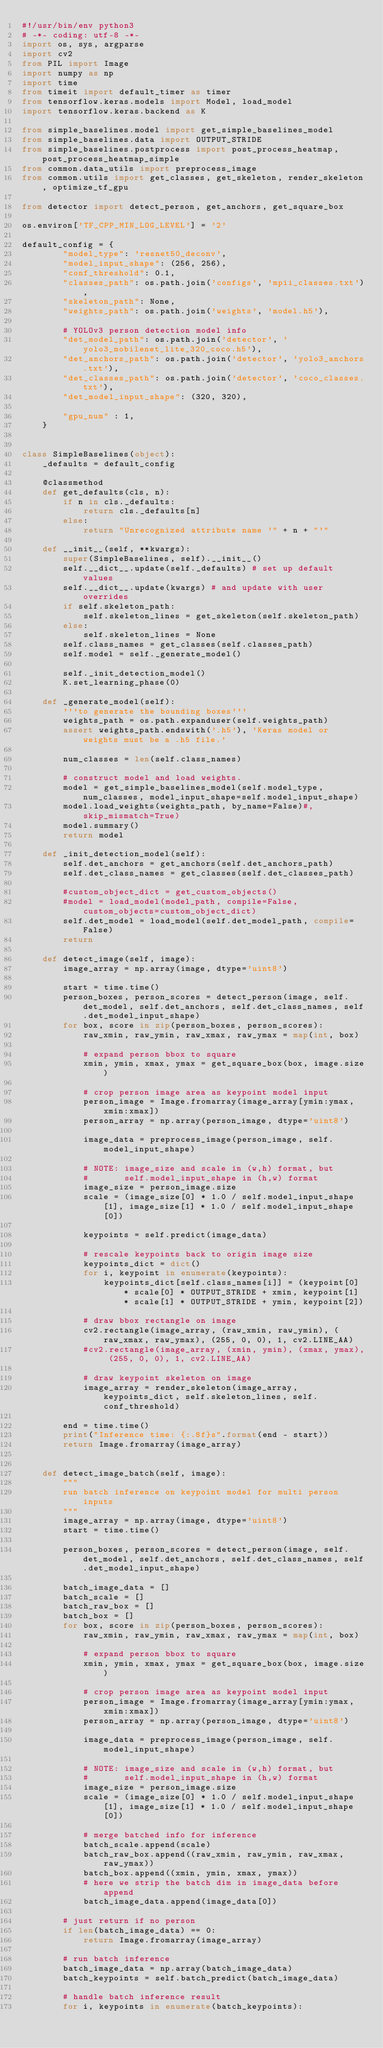<code> <loc_0><loc_0><loc_500><loc_500><_Python_>#!/usr/bin/env python3
# -*- coding: utf-8 -*-
import os, sys, argparse
import cv2
from PIL import Image
import numpy as np
import time
from timeit import default_timer as timer
from tensorflow.keras.models import Model, load_model
import tensorflow.keras.backend as K

from simple_baselines.model import get_simple_baselines_model
from simple_baselines.data import OUTPUT_STRIDE
from simple_baselines.postprocess import post_process_heatmap, post_process_heatmap_simple
from common.data_utils import preprocess_image
from common.utils import get_classes, get_skeleton, render_skeleton, optimize_tf_gpu

from detector import detect_person, get_anchors, get_square_box

os.environ['TF_CPP_MIN_LOG_LEVEL'] = '2'

default_config = {
        "model_type": 'resnet50_deconv',
        "model_input_shape": (256, 256),
        "conf_threshold": 0.1,
        "classes_path": os.path.join('configs', 'mpii_classes.txt'),
        "skeleton_path": None,
        "weights_path": os.path.join('weights', 'model.h5'),

        # YOLOv3 person detection model info
        "det_model_path": os.path.join('detector', 'yolo3_mobilenet_lite_320_coco.h5'),
        "det_anchors_path": os.path.join('detector', 'yolo3_anchors.txt'),
        "det_classes_path": os.path.join('detector', 'coco_classes.txt'),
        "det_model_input_shape": (320, 320),

        "gpu_num" : 1,
    }


class SimpleBaselines(object):
    _defaults = default_config

    @classmethod
    def get_defaults(cls, n):
        if n in cls._defaults:
            return cls._defaults[n]
        else:
            return "Unrecognized attribute name '" + n + "'"

    def __init__(self, **kwargs):
        super(SimpleBaselines, self).__init__()
        self.__dict__.update(self._defaults) # set up default values
        self.__dict__.update(kwargs) # and update with user overrides
        if self.skeleton_path:
            self.skeleton_lines = get_skeleton(self.skeleton_path)
        else:
            self.skeleton_lines = None
        self.class_names = get_classes(self.classes_path)
        self.model = self._generate_model()

        self._init_detection_model()
        K.set_learning_phase(0)

    def _generate_model(self):
        '''to generate the bounding boxes'''
        weights_path = os.path.expanduser(self.weights_path)
        assert weights_path.endswith('.h5'), 'Keras model or weights must be a .h5 file.'

        num_classes = len(self.class_names)

        # construct model and load weights.
        model = get_simple_baselines_model(self.model_type, num_classes, model_input_shape=self.model_input_shape)
        model.load_weights(weights_path, by_name=False)#, skip_mismatch=True)
        model.summary()
        return model

    def _init_detection_model(self):
        self.det_anchors = get_anchors(self.det_anchors_path)
        self.det_class_names = get_classes(self.det_classes_path)

        #custom_object_dict = get_custom_objects()
        #model = load_model(model_path, compile=False, custom_objects=custom_object_dict)
        self.det_model = load_model(self.det_model_path, compile=False)
        return

    def detect_image(self, image):
        image_array = np.array(image, dtype='uint8')

        start = time.time()
        person_boxes, person_scores = detect_person(image, self.det_model, self.det_anchors, self.det_class_names, self.det_model_input_shape)
        for box, score in zip(person_boxes, person_scores):
            raw_xmin, raw_ymin, raw_xmax, raw_ymax = map(int, box)

            # expand person bbox to square
            xmin, ymin, xmax, ymax = get_square_box(box, image.size)

            # crop person image area as keypoint model input
            person_image = Image.fromarray(image_array[ymin:ymax, xmin:xmax])
            person_array = np.array(person_image, dtype='uint8')

            image_data = preprocess_image(person_image, self.model_input_shape)

            # NOTE: image_size and scale in (w,h) format, but
            #       self.model_input_shape in (h,w) format
            image_size = person_image.size
            scale = (image_size[0] * 1.0 / self.model_input_shape[1], image_size[1] * 1.0 / self.model_input_shape[0])

            keypoints = self.predict(image_data)

            # rescale keypoints back to origin image size
            keypoints_dict = dict()
            for i, keypoint in enumerate(keypoints):
                keypoints_dict[self.class_names[i]] = (keypoint[0] * scale[0] * OUTPUT_STRIDE + xmin, keypoint[1] * scale[1] * OUTPUT_STRIDE + ymin, keypoint[2])

            # draw bbox rectangle on image
            cv2.rectangle(image_array, (raw_xmin, raw_ymin), (raw_xmax, raw_ymax), (255, 0, 0), 1, cv2.LINE_AA)
            #cv2.rectangle(image_array, (xmin, ymin), (xmax, ymax), (255, 0, 0), 1, cv2.LINE_AA)

            # draw keypoint skeleton on image
            image_array = render_skeleton(image_array, keypoints_dict, self.skeleton_lines, self.conf_threshold)

        end = time.time()
        print("Inference time: {:.8f}s".format(end - start))
        return Image.fromarray(image_array)


    def detect_image_batch(self, image):
        """
        run batch inference on keypoint model for multi person inputs
        """
        image_array = np.array(image, dtype='uint8')
        start = time.time()

        person_boxes, person_scores = detect_person(image, self.det_model, self.det_anchors, self.det_class_names, self.det_model_input_shape)

        batch_image_data = []
        batch_scale = []
        batch_raw_box = []
        batch_box = []
        for box, score in zip(person_boxes, person_scores):
            raw_xmin, raw_ymin, raw_xmax, raw_ymax = map(int, box)

            # expand person bbox to square
            xmin, ymin, xmax, ymax = get_square_box(box, image.size)

            # crop person image area as keypoint model input
            person_image = Image.fromarray(image_array[ymin:ymax, xmin:xmax])
            person_array = np.array(person_image, dtype='uint8')

            image_data = preprocess_image(person_image, self.model_input_shape)

            # NOTE: image_size and scale in (w,h) format, but
            #       self.model_input_shape in (h,w) format
            image_size = person_image.size
            scale = (image_size[0] * 1.0 / self.model_input_shape[1], image_size[1] * 1.0 / self.model_input_shape[0])

            # merge batched info for inference
            batch_scale.append(scale)
            batch_raw_box.append((raw_xmin, raw_ymin, raw_xmax, raw_ymax))
            batch_box.append((xmin, ymin, xmax, ymax))
            # here we strip the batch dim in image_data before append
            batch_image_data.append(image_data[0])

        # just return if no person
        if len(batch_image_data) == 0:
            return Image.fromarray(image_array)

        # run batch inference
        batch_image_data = np.array(batch_image_data)
        batch_keypoints = self.batch_predict(batch_image_data)

        # handle batch inference result
        for i, keypoints in enumerate(batch_keypoints):</code> 